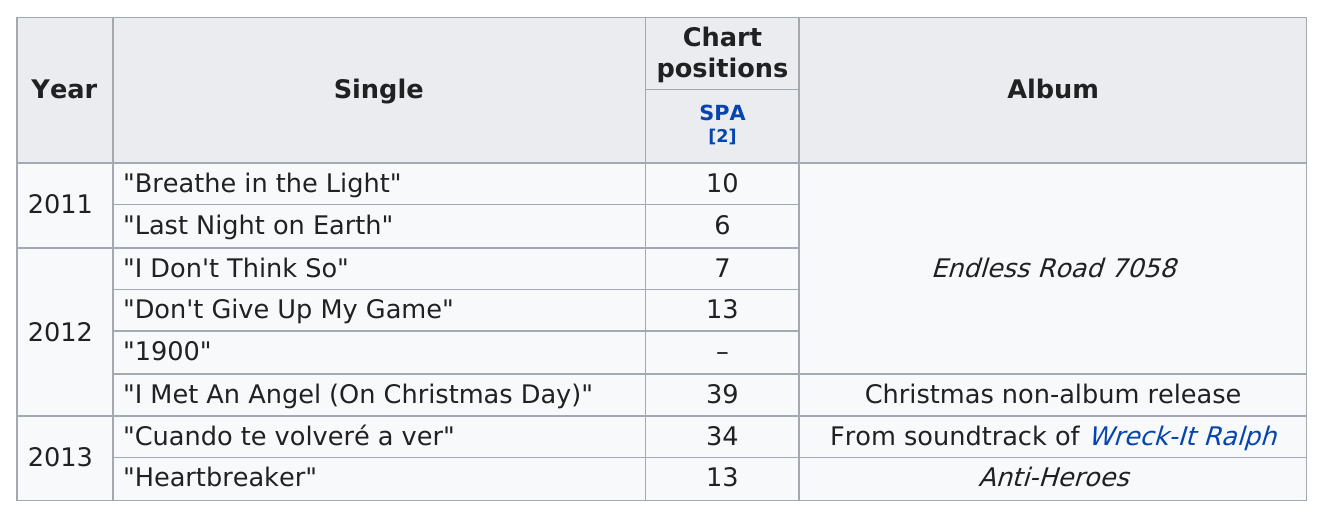Identify some key points in this picture. Based on sales figures, it can be declared that Auryn's most popular album is "Endless Road 7058. The band Auryn released a total of 8 singles between 2011 and 2013. In the year 2012, there were 4 singles. 